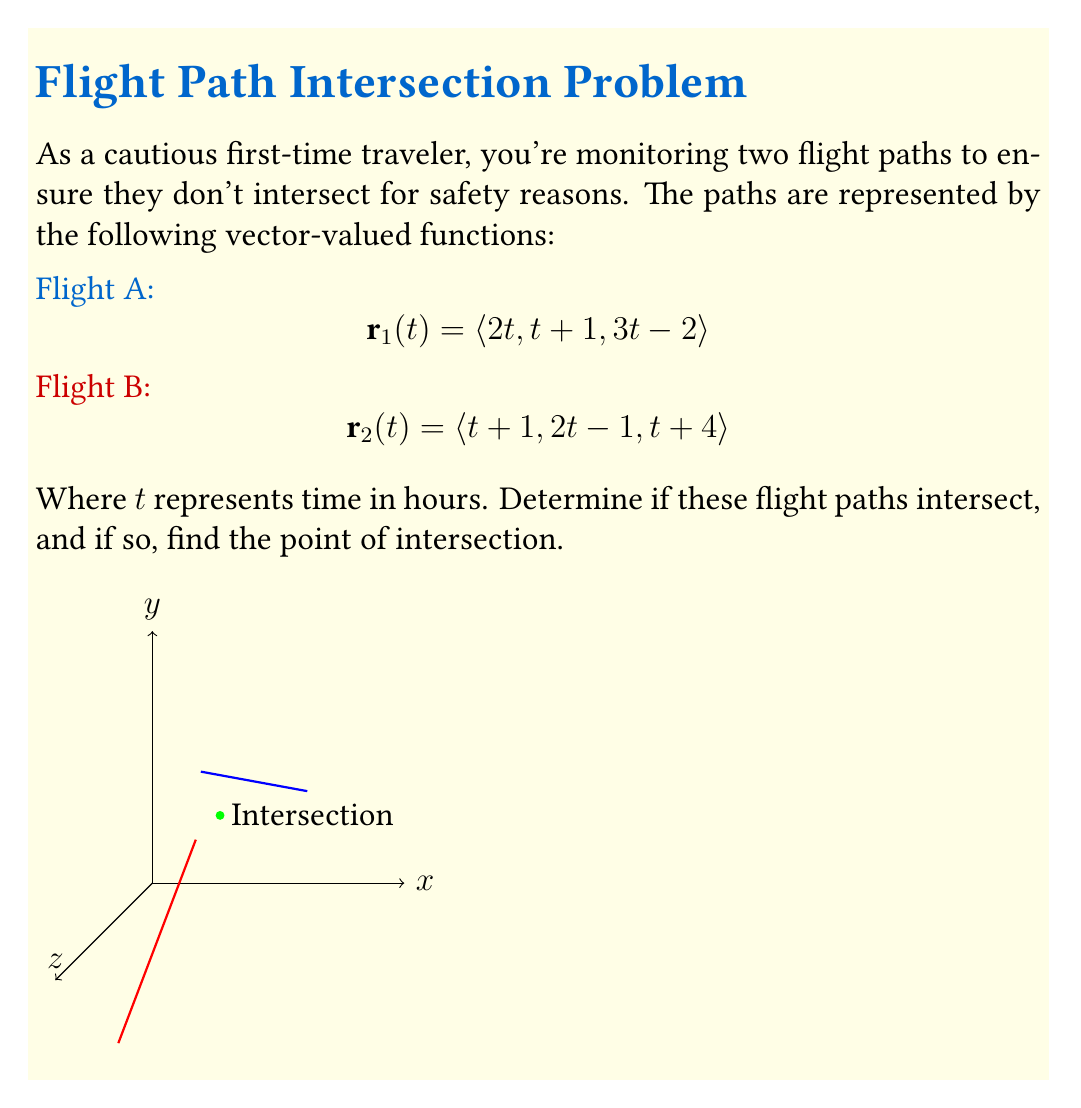Show me your answer to this math problem. To find if the flight paths intersect, we need to equate the vector-valued functions and solve for $t$:

$$\mathbf{r}_1(t_1) = \mathbf{r}_2(t_2)$$

This gives us three equations:

1) $2t_1 = t_2 + 1$
2) $t_1 + 1 = 2t_2 - 1$
3) $3t_1 - 2 = t_2 + 4$

From equation 1:
$$t_2 = 2t_1 - 1$$

Substituting this into equation 2:
$$t_1 + 1 = 2(2t_1 - 1) - 1$$
$$t_1 + 1 = 4t_1 - 3$$
$$4 = 3t_1$$
$$t_1 = \frac{4}{3}$$

Now we can find $t_2$:
$$t_2 = 2(\frac{4}{3}) - 1 = \frac{8}{3} - 1 = \frac{5}{3}$$

Let's verify using equation 3:
$$3(\frac{4}{3}) - 2 = \frac{5}{3} + 4$$
$$4 - 2 = \frac{5}{3} + 4$$
$$2 = \frac{5}{3} + 4$$
$$2 = \frac{17}{3}$$

This is true, so our solution is correct.

To find the intersection point, we can substitute $t_1 = \frac{4}{3}$ into $\mathbf{r}_1(t)$:

$$\mathbf{r}_1(\frac{4}{3}) = \langle 2(\frac{4}{3}), \frac{4}{3}+1, 3(\frac{4}{3})-2 \rangle = \langle \frac{8}{3}, \frac{7}{3}, 2 \rangle = \langle 3, 3, 5 \rangle$$

Therefore, the flight paths intersect at the point (3, 3, 5).
Answer: (3, 3, 5) 